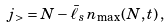<formula> <loc_0><loc_0><loc_500><loc_500>j _ { > } = N - \bar { \ell } _ { s } \, n _ { \max } ( N , t ) \, ,</formula> 